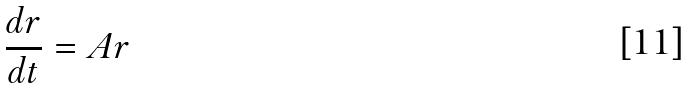Convert formula to latex. <formula><loc_0><loc_0><loc_500><loc_500>\frac { d r } { d t } = A r</formula> 